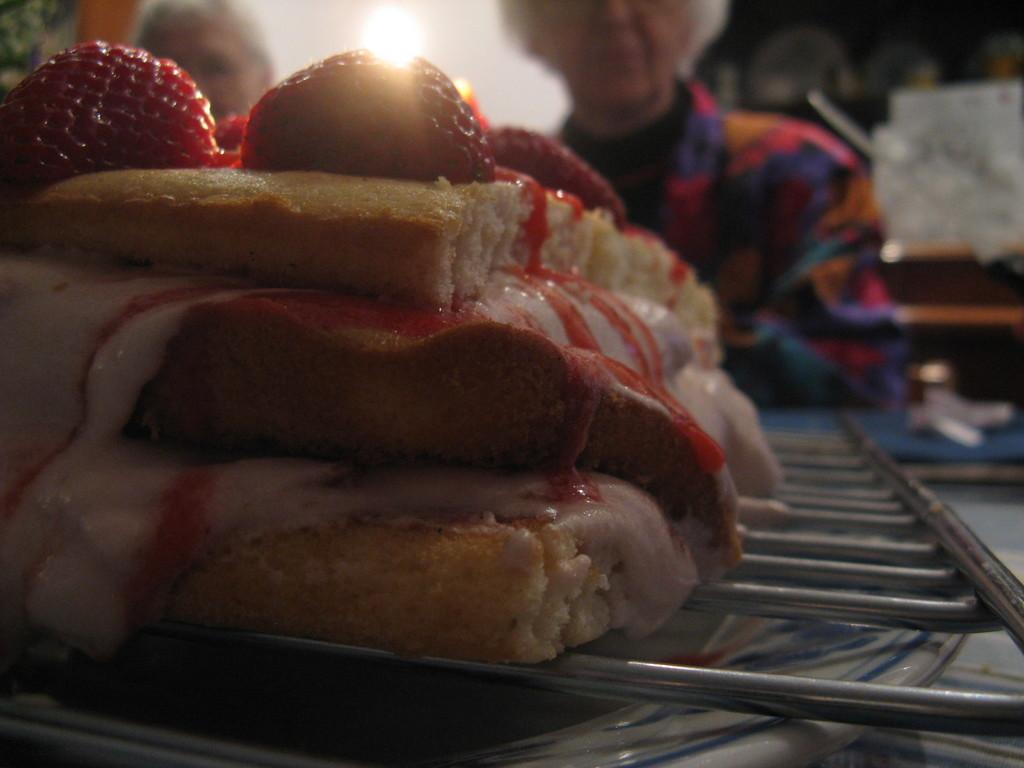What is being cooked in the image? There is food on a grill in the image. What can be seen in the background of the image? There are people and some objects visible in the background of the image. What type of map is being used by the judge in the image? There is no map or judge present in the image. What type of produce is being harvested by the people in the image? There is no produce or harvesting activity visible in the image. 